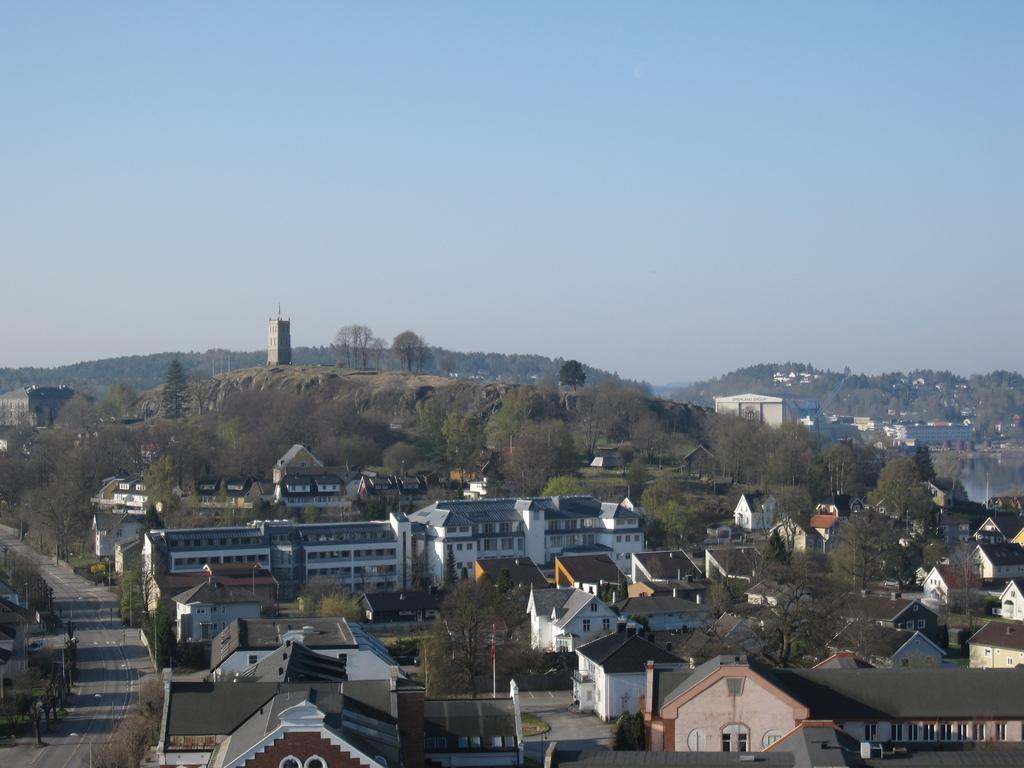What is the main feature of the image? There is a road in the image. What else can be seen along the road? There are poles, trees, and buildings visible in the image. What is in the background of the image? In the background, there is a mountain with buildings and trees on it, water visible, and the sky. What type of straw is being used to blow the leaves in the image? There are no leaves or straws present in the image. 